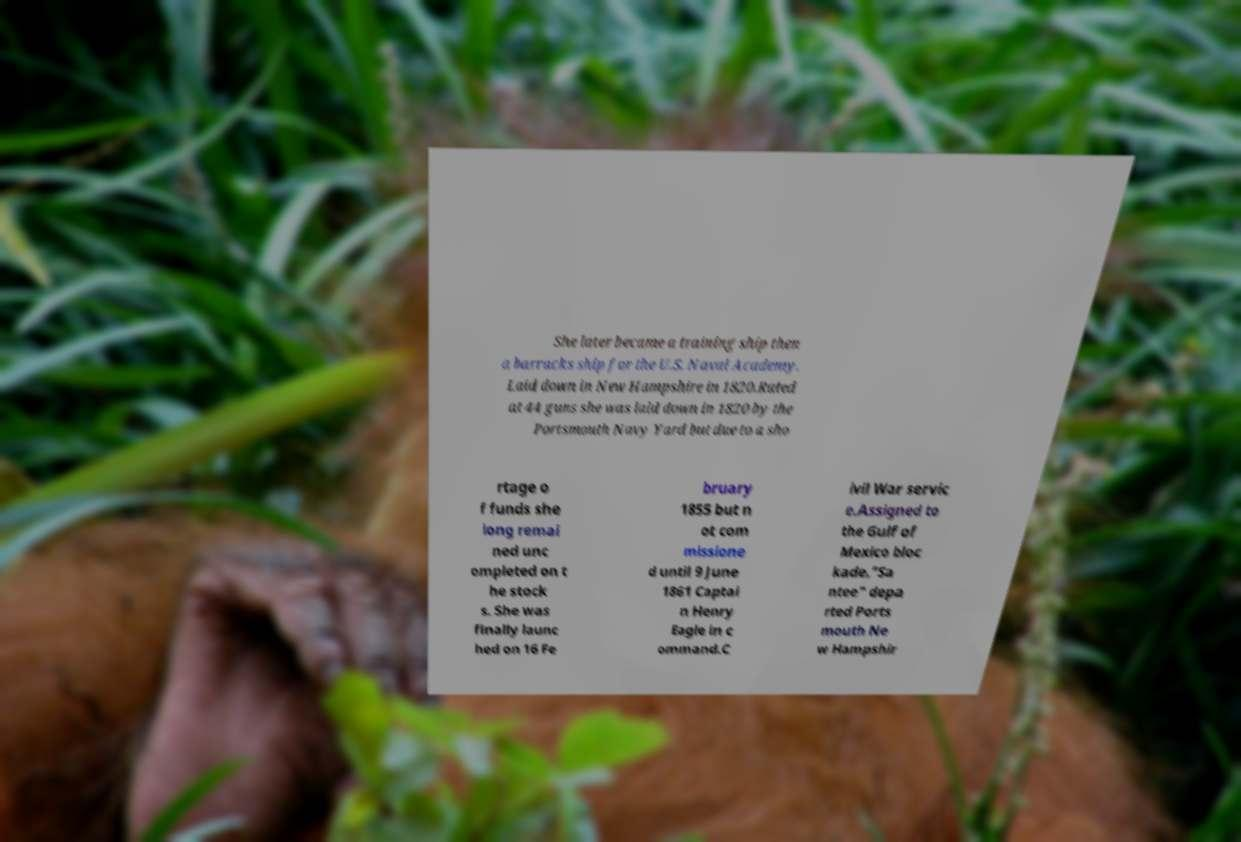Can you read and provide the text displayed in the image?This photo seems to have some interesting text. Can you extract and type it out for me? She later became a training ship then a barracks ship for the U.S. Naval Academy. Laid down in New Hampshire in 1820.Rated at 44 guns she was laid down in 1820 by the Portsmouth Navy Yard but due to a sho rtage o f funds she long remai ned unc ompleted on t he stock s. She was finally launc hed on 16 Fe bruary 1855 but n ot com missione d until 9 June 1861 Captai n Henry Eagle in c ommand.C ivil War servic e.Assigned to the Gulf of Mexico bloc kade."Sa ntee" depa rted Ports mouth Ne w Hampshir 